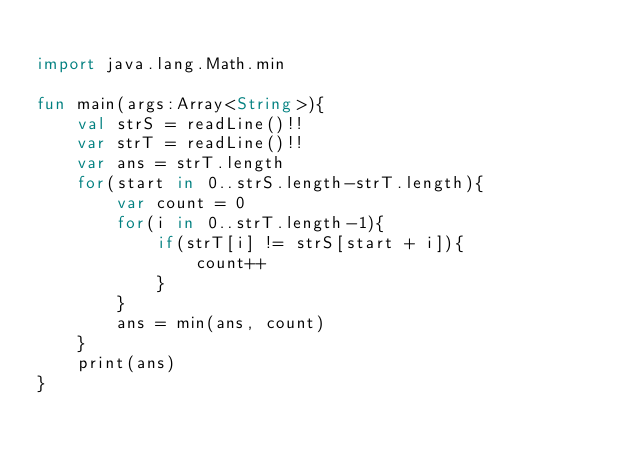<code> <loc_0><loc_0><loc_500><loc_500><_Kotlin_>
import java.lang.Math.min

fun main(args:Array<String>){
    val strS = readLine()!!
    var strT = readLine()!!
    var ans = strT.length
    for(start in 0..strS.length-strT.length){
        var count = 0
        for(i in 0..strT.length-1){
            if(strT[i] != strS[start + i]){
                count++
            }
        }
        ans = min(ans, count)
    }
    print(ans)
}</code> 